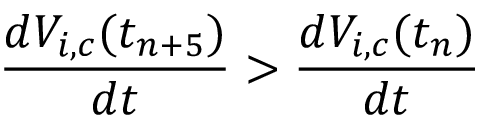Convert formula to latex. <formula><loc_0><loc_0><loc_500><loc_500>\frac { d V _ { i , c } ( t _ { n + 5 } ) } { d t } > \frac { d V _ { i , c } ( t _ { n } ) } { d t }</formula> 